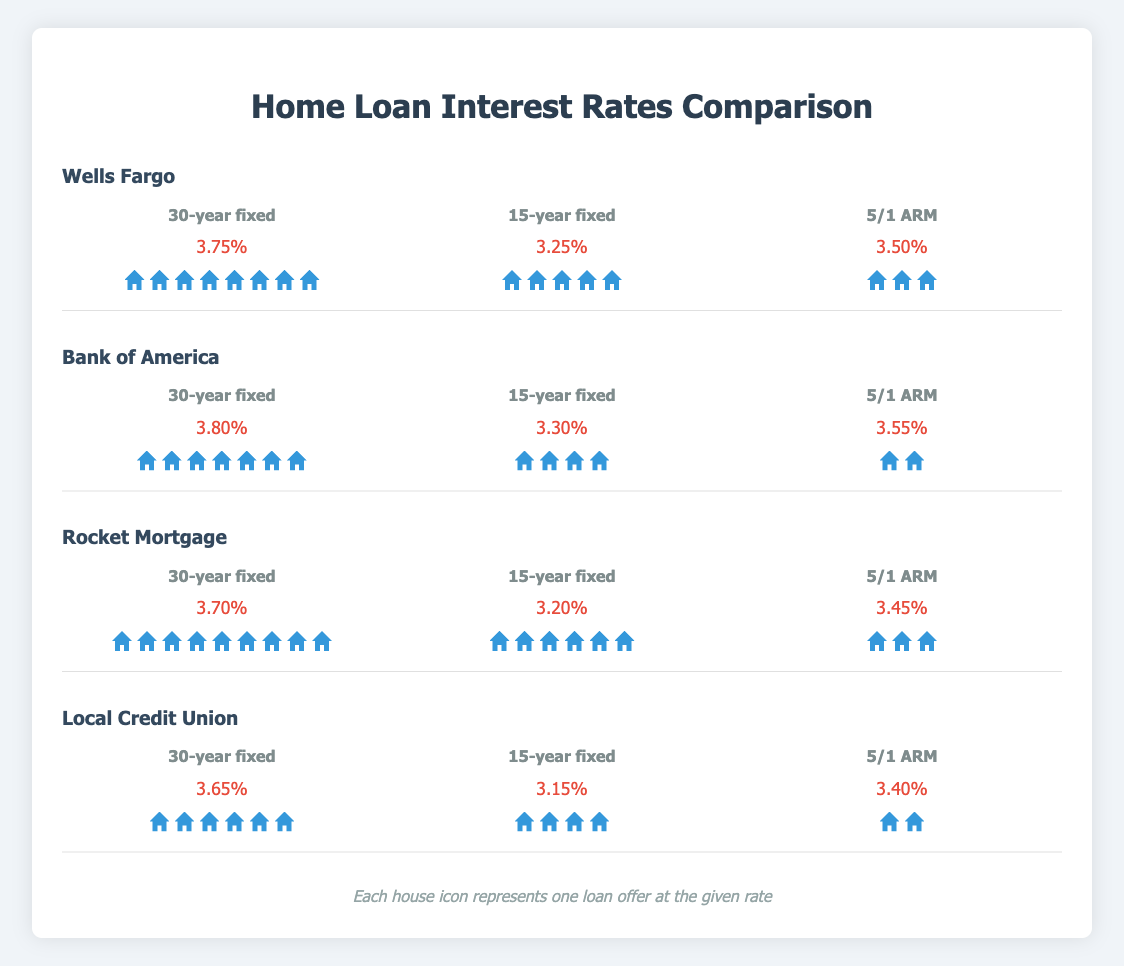What is the interest rate for a 30-year fixed loan from Rocket Mortgage? You can look under the section for Rocket Mortgage and find the rate for a 30-year fixed loan type.
Answer: 3.70% How many 5/1 ARM loans are offered by Wells Fargo? Check the house icons under the 5/1 ARM loan type for Wells Fargo. Each house icon represents one loan offer.
Answer: 3 Which lender offers the lowest interest rate for a 15-year fixed loan? Compare the interest rates for 15-year fixed loans across all lenders and find the lowest rate. Wells Fargo: 3.25%, Bank of America: 3.30%, Rocket Mortgage: 3.20%, Local Credit Union: 3.15%.
Answer: Local Credit Union Which 30-year fixed loan has a higher interest rate, Wells Fargo or Bank of America? Compare the interest rates for 30-year fixed loans from Wells Fargo (3.75%) and Bank of America (3.80%).
Answer: Bank of America What is the average interest rate for a 5/1 ARM loan across all lenders? Sum up the interest rates for 5/1 ARM loans from all lenders and divide by the number of lenders. (3.50 + 3.55 + 3.45 + 3.40) / 4 = 3.475.
Answer: 3.475% How many 30-year fixed loan offers are there in total? Sum up the number of house icons under the 30-year fixed loan type for all lenders: Wells Fargo (8), Bank of America (7), Rocket Mortgage (9), Local Credit Union (6).
Answer: 30 Which lender has the highest number of loan offers for a 15-year fixed loan? Compare the number of house icons under the 15-year fixed loan type for all lenders and find the one with the highest count: Wells Fargo (5), Bank of America (4), Rocket Mortgage (6), Local Credit Union (4).
Answer: Rocket Mortgage Is there any lender that offers the same number of 5/1 ARM loans? Compare the number of house icons under the 5/1 ARM loan type across all lenders to see if there are any with the same count: Wells Fargo (3), Bank of America (2), Rocket Mortgage (3), Local Credit Union (2).
Answer: Yes, Bank of America and Local Credit Union 